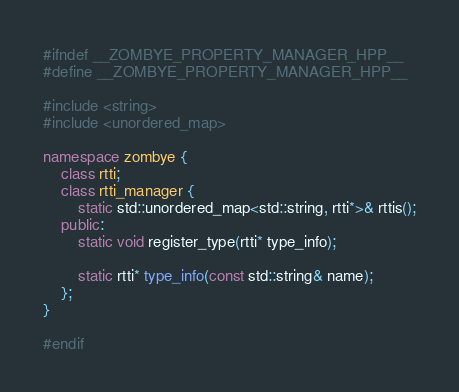Convert code to text. <code><loc_0><loc_0><loc_500><loc_500><_C++_>#ifndef __ZOMBYE_PROPERTY_MANAGER_HPP__
#define __ZOMBYE_PROPERTY_MANAGER_HPP__

#include <string>
#include <unordered_map>

namespace zombye {
    class rtti;
    class rtti_manager {
        static std::unordered_map<std::string, rtti*>& rttis();
    public:
        static void register_type(rtti* type_info);

        static rtti* type_info(const std::string& name);
    };
}

#endif
</code> 